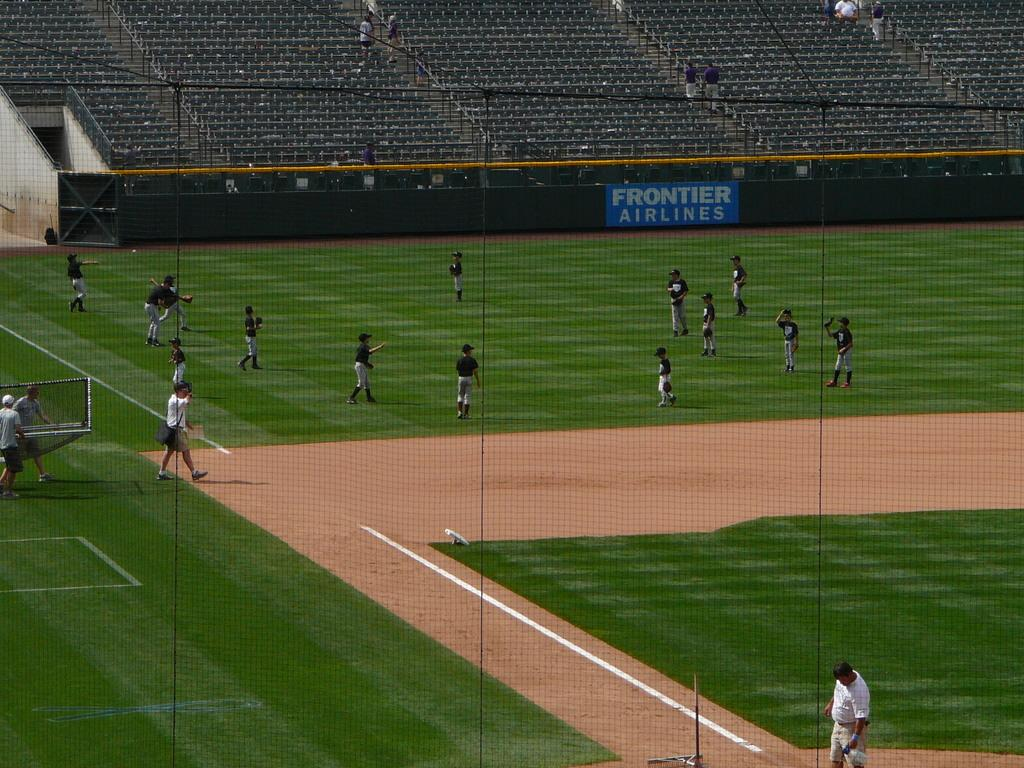<image>
Write a terse but informative summary of the picture. A team practices on a baseball field by a sign that says Frontier Airlines. 